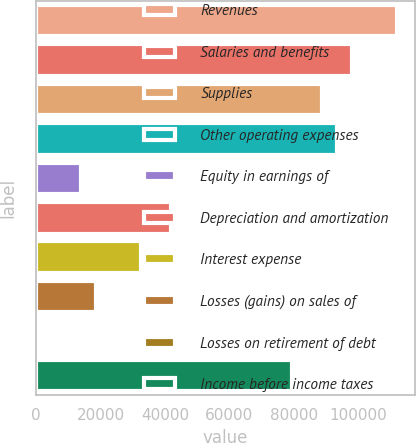Convert chart. <chart><loc_0><loc_0><loc_500><loc_500><bar_chart><fcel>Revenues<fcel>Salaries and benefits<fcel>Supplies<fcel>Other operating expenses<fcel>Equity in earnings of<fcel>Depreciation and amortization<fcel>Interest expense<fcel>Losses (gains) on sales of<fcel>Losses on retirement of debt<fcel>Income before income taxes<nl><fcel>112012<fcel>98011.8<fcel>88678.2<fcel>93345<fcel>14009.4<fcel>42010.2<fcel>32676.6<fcel>18676.2<fcel>9<fcel>79344.6<nl></chart> 